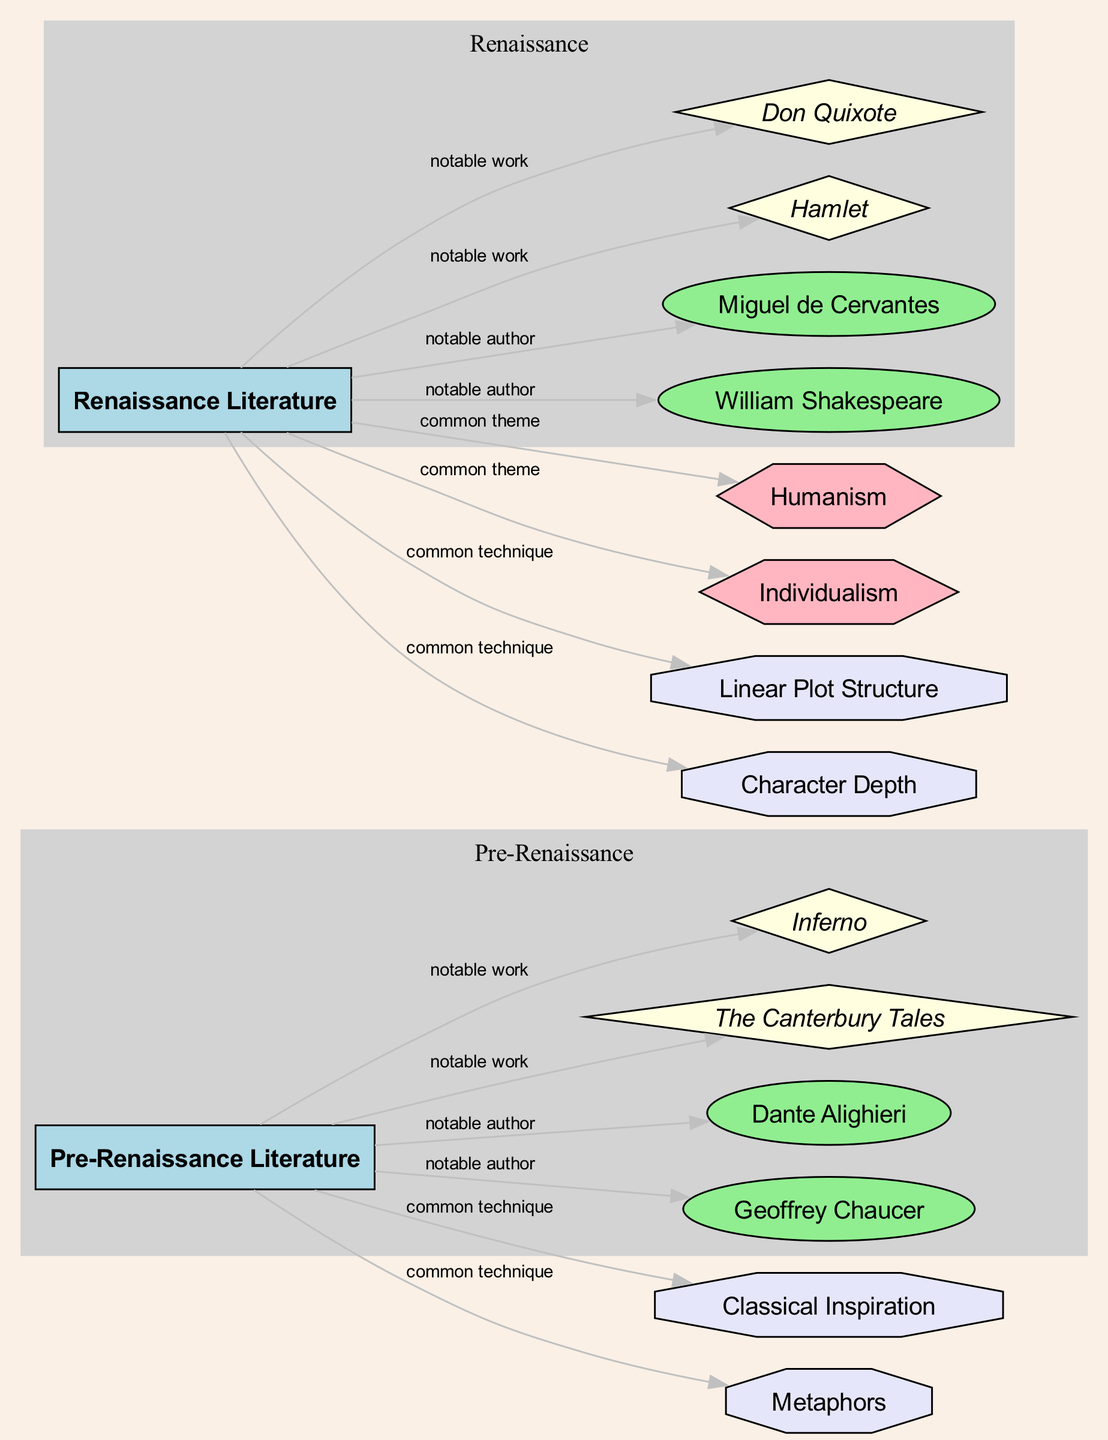What are the notable works of Pre-Renaissance Literature? The diagram indicates that "The Canterbury Tales" and "Inferno" are notable works under the Pre-Renaissance Literature category, as they are directly connected to the Pre-Renaissance node.
Answer: The Canterbury Tales, Inferno Who is a notable author from Renaissance Literature? The diagram shows "William Shakespeare" and "Miguel de Cervantes" as notable authors connected to the Renaissance Literature category, making either of them a correct answer.
Answer: William Shakespeare What common theme is associated with Renaissance Literature? The diagram specifies "Humanism" and "Individualism" as common themes linked to the Renaissance Literature node, so either can be considered correct.
Answer: Humanism How many notable authors are there in Pre-Renaissance Literature? The diagram illustrates that there are two notable authors, Geoffrey Chaucer and Dante Alighieri, connected to the Pre-Renaissance Literature node. Counting them gives a total of two.
Answer: 2 What literary technique is commonly used in Pre-Renaissance Literature? The diagram lists "Classical Inspiration" and "Metaphors" as common techniques under Pre-Renaissance Literature, hence either could be a valid response.
Answer: Classical Inspiration Explain how the themes of Humanism and Individualism relate to Renaissance Literature. The diagram shows that both "Humanism" and "Individualism" are common themes linked directly to the Renaissance Literature category, suggesting that these themes characterize the literature from this period. By understanding this relationship, we can discern how literature from the Renaissance places emphasis on human values and personal experiences.
Answer: Humanism, Individualism What is a notable work of William Shakespeare? The diagram identifies "Hamlet" as a notable work connected to the node of William Shakespeare, thus making it the correct response.
Answer: Hamlet Which literary technique reflects character development in Renaissance Literature? The diagram specifies "Character Depth" as a literary technique associated with Renaissance Literature, which is indicative of deeper character exploration by authors during this period.
Answer: Character Depth 